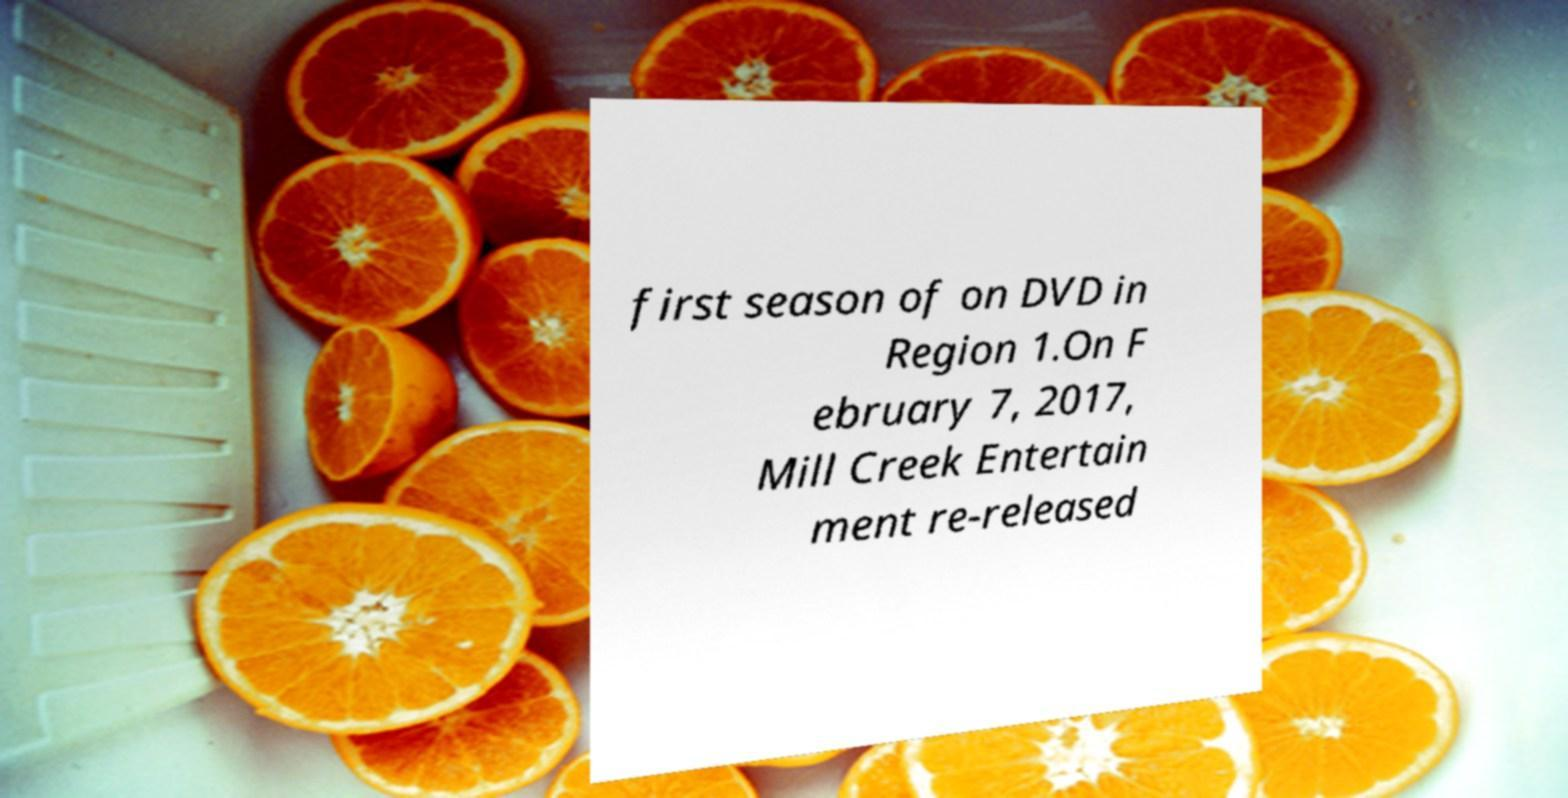Could you extract and type out the text from this image? first season of on DVD in Region 1.On F ebruary 7, 2017, Mill Creek Entertain ment re-released 